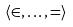Convert formula to latex. <formula><loc_0><loc_0><loc_500><loc_500>\langle \in , \dots , = \rangle</formula> 